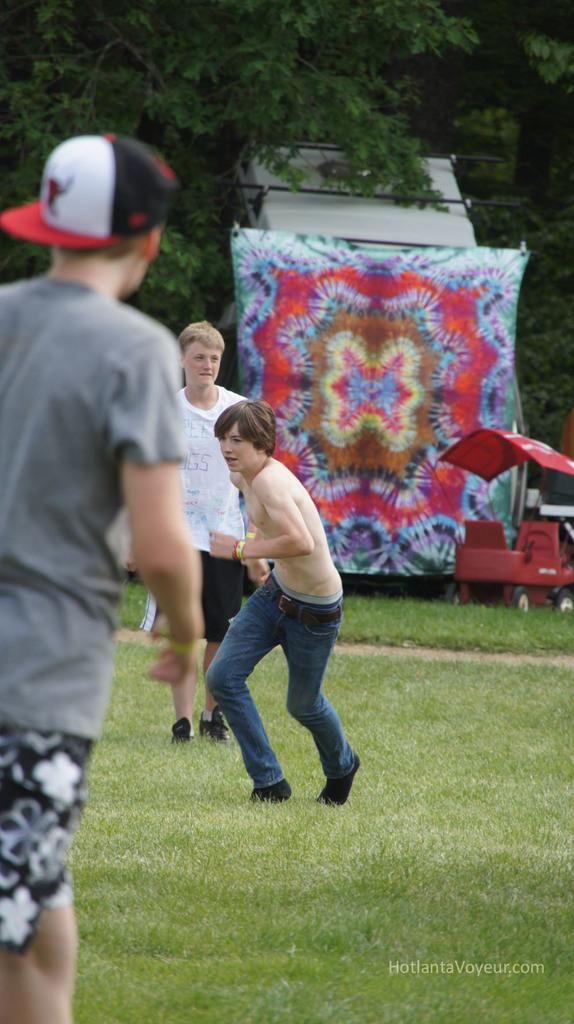Who or what can be seen in the image? There are people in the image. What type of surface is under the people's feet? There is grass on the ground in the image. What can be seen in the distance behind the people? There are objects and trees visible in the background of the image. Is there any text present in the image? Yes, there is some text visible in the bottom right of the image. What type of plantation is visible in the image? There is no plantation present in the image. How many people are seen crushing objects in the image? There is no indication of people crushing objects in the image. 